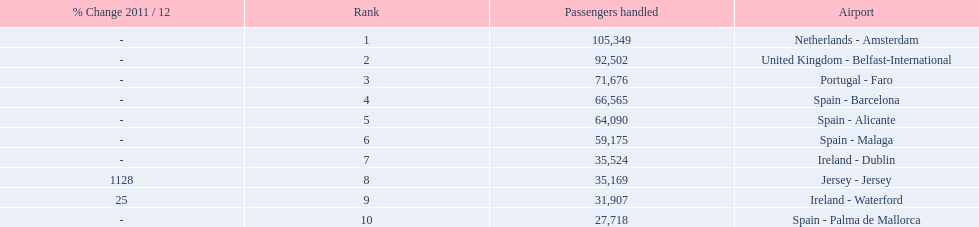What is the highest number of passengers handled? 105,349. What is the destination of the passengers leaving the area that handles 105,349 travellers? Netherlands - Amsterdam. 